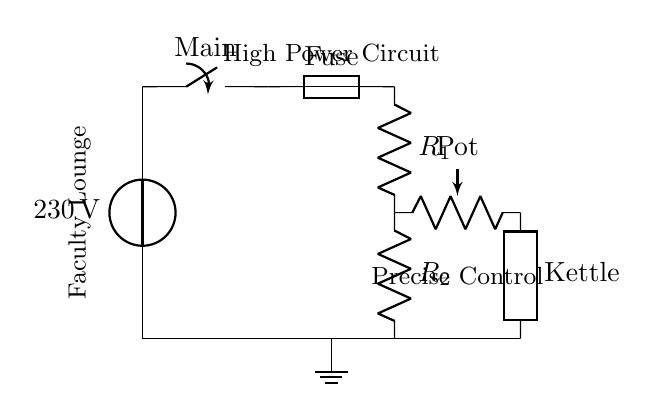What is the source voltage in this circuit? The source voltage is indicated as 230 volts in the diagram, which is the potential difference supplied to the circuit.
Answer: 230 volts What type of component is the kettle in this diagram? The kettle is labeled as a generic component, shown as a "Kettle" in the circuit, indicating it is a load that uses electrical power.
Answer: Kettle What is the function of the potentiometer in the circuit? The potentiometer serves as an adjustable resistance, allowing for precise control of the voltage across the kettle, thereby controlling its power.
Answer: Precise control How many resistors are part of the voltage divider? There are two resistors in the voltage divider, labeled as R1 and R2, which are used to divide the voltage supplied to the kettle.
Answer: Two resistors What is the specific purpose of the switch in this circuit? The switch functions as a main control mechanism that can open or close the circuit, allowing or stopping the flow of electricity to the kettle.
Answer: Main switch What could happen if the voltage across the kettle is too high? If the voltage across the kettle exceeds its rated specification, it could lead to overheating or damage to the kettle, potentially causing failure or safety hazards.
Answer: Overheating Which component protects the circuit from overloads? The fuse acts as a protective device in the circuit, designed to break the circuit if the current exceeds a safe level, thus preventing potential damage.
Answer: Fuse 